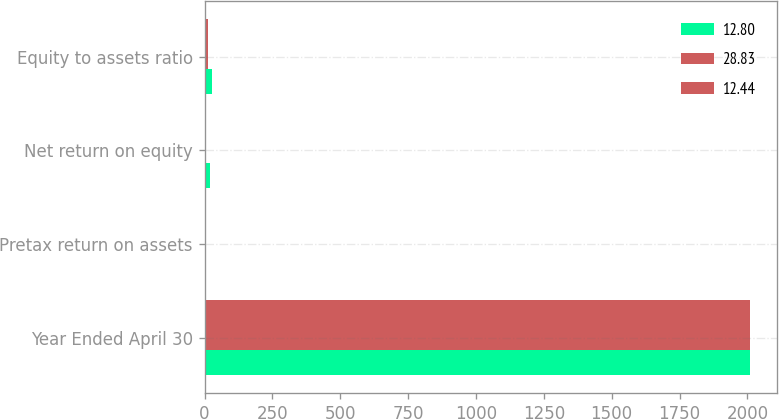Convert chart to OTSL. <chart><loc_0><loc_0><loc_500><loc_500><stacked_bar_chart><ecel><fcel>Year Ended April 30<fcel>Pretax return on assets<fcel>Net return on equity<fcel>Equity to assets ratio<nl><fcel>12.8<fcel>2010<fcel>2.12<fcel>21.04<fcel>28.83<nl><fcel>28.83<fcel>2009<fcel>1.03<fcel>6.67<fcel>12.44<nl><fcel>12.44<fcel>2008<fcel>0.8<fcel>3.32<fcel>12.8<nl></chart> 